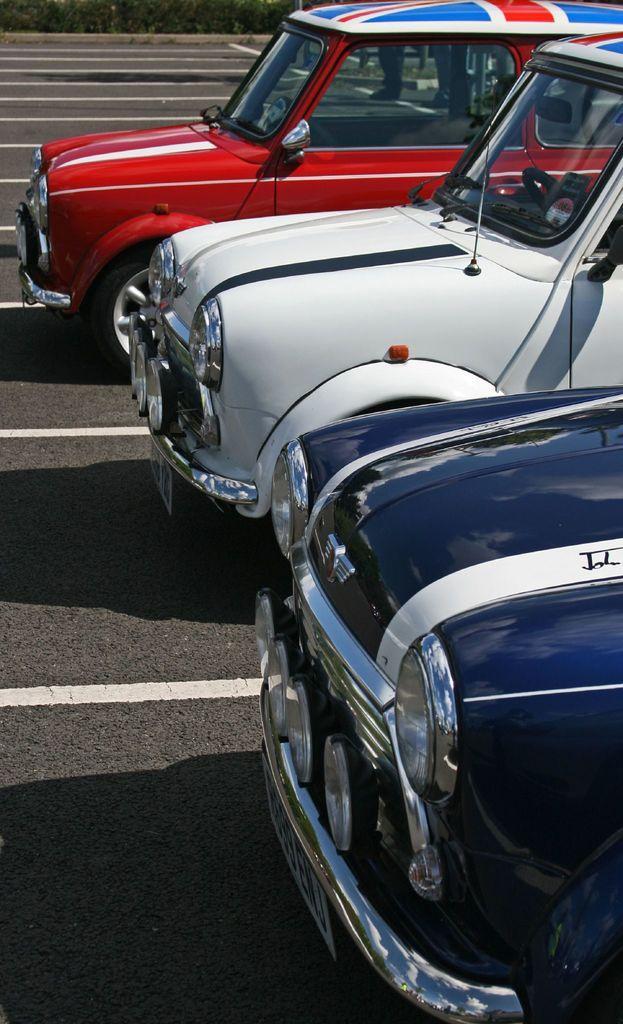Describe this image in one or two sentences. In the picture I can see three cars on the road. I can also see white color lines on the road. 